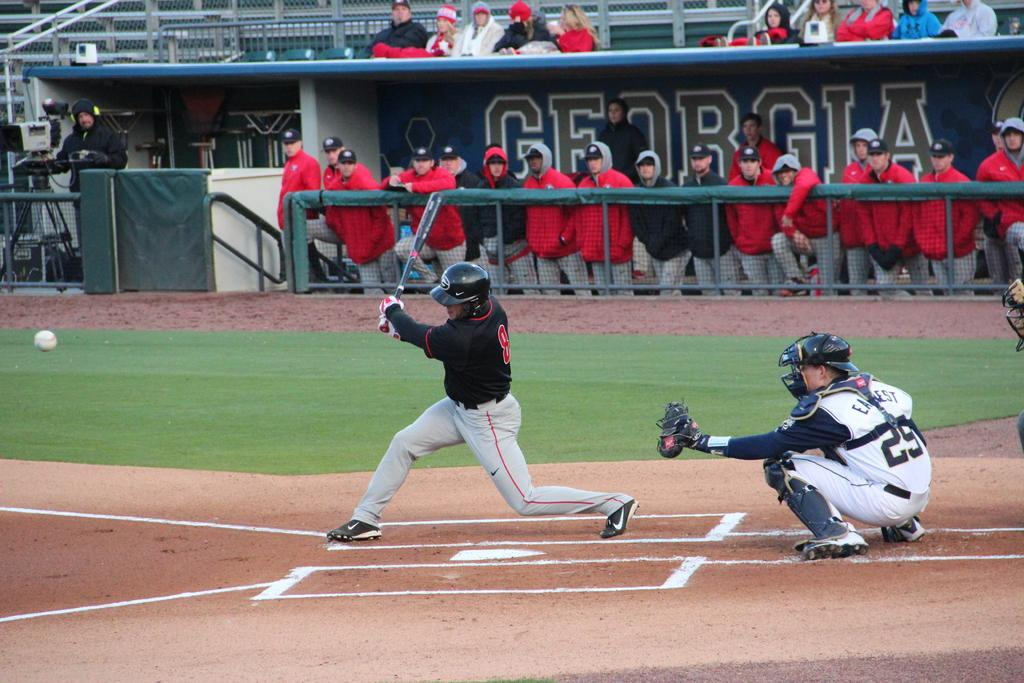Provide a one-sentence caption for the provided image. a dugout that has the state name of Georgia in it. 